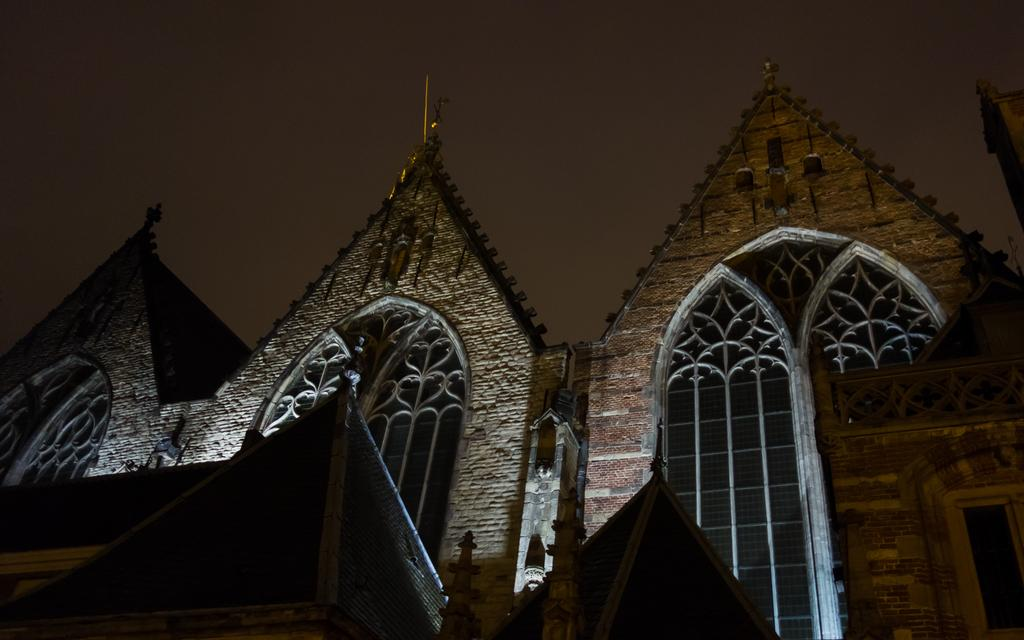What can be seen at the top of the image? The sky is visible towards the top of the image. What is located towards the bottom of the image? There is a building towards the bottom of the image. What type of structure is present in the image? There is a wall in the image. What type of cub is playing with the wheel in the image? There is no cub or wheel present in the image. What subject is being taught in the image? There is no teaching or classroom scene depicted in the image. 